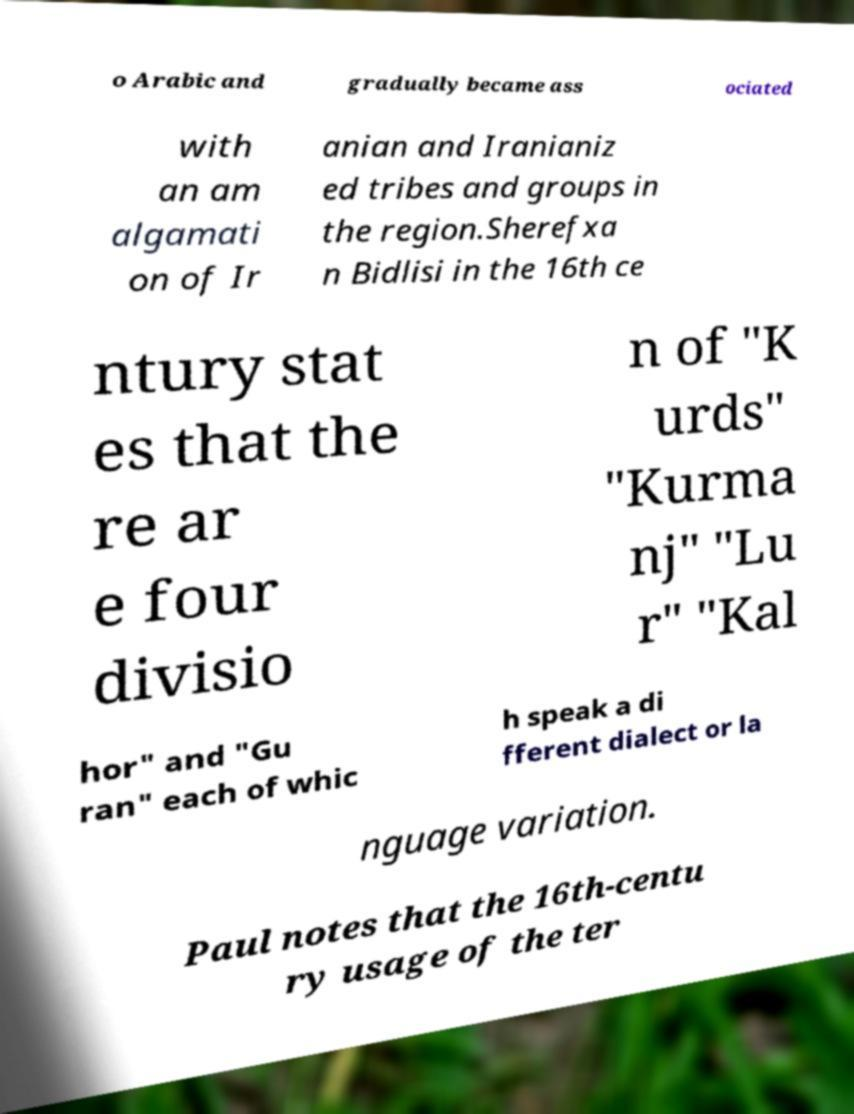There's text embedded in this image that I need extracted. Can you transcribe it verbatim? o Arabic and gradually became ass ociated with an am algamati on of Ir anian and Iranianiz ed tribes and groups in the region.Sherefxa n Bidlisi in the 16th ce ntury stat es that the re ar e four divisio n of "K urds" "Kurma nj" "Lu r" "Kal hor" and "Gu ran" each of whic h speak a di fferent dialect or la nguage variation. Paul notes that the 16th-centu ry usage of the ter 